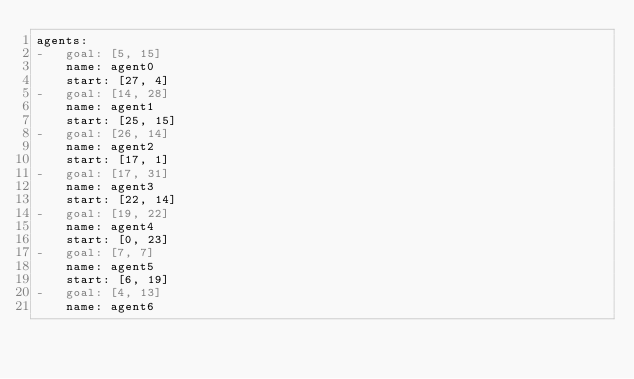<code> <loc_0><loc_0><loc_500><loc_500><_YAML_>agents:
-   goal: [5, 15]
    name: agent0
    start: [27, 4]
-   goal: [14, 28]
    name: agent1
    start: [25, 15]
-   goal: [26, 14]
    name: agent2
    start: [17, 1]
-   goal: [17, 31]
    name: agent3
    start: [22, 14]
-   goal: [19, 22]
    name: agent4
    start: [0, 23]
-   goal: [7, 7]
    name: agent5
    start: [6, 19]
-   goal: [4, 13]
    name: agent6</code> 